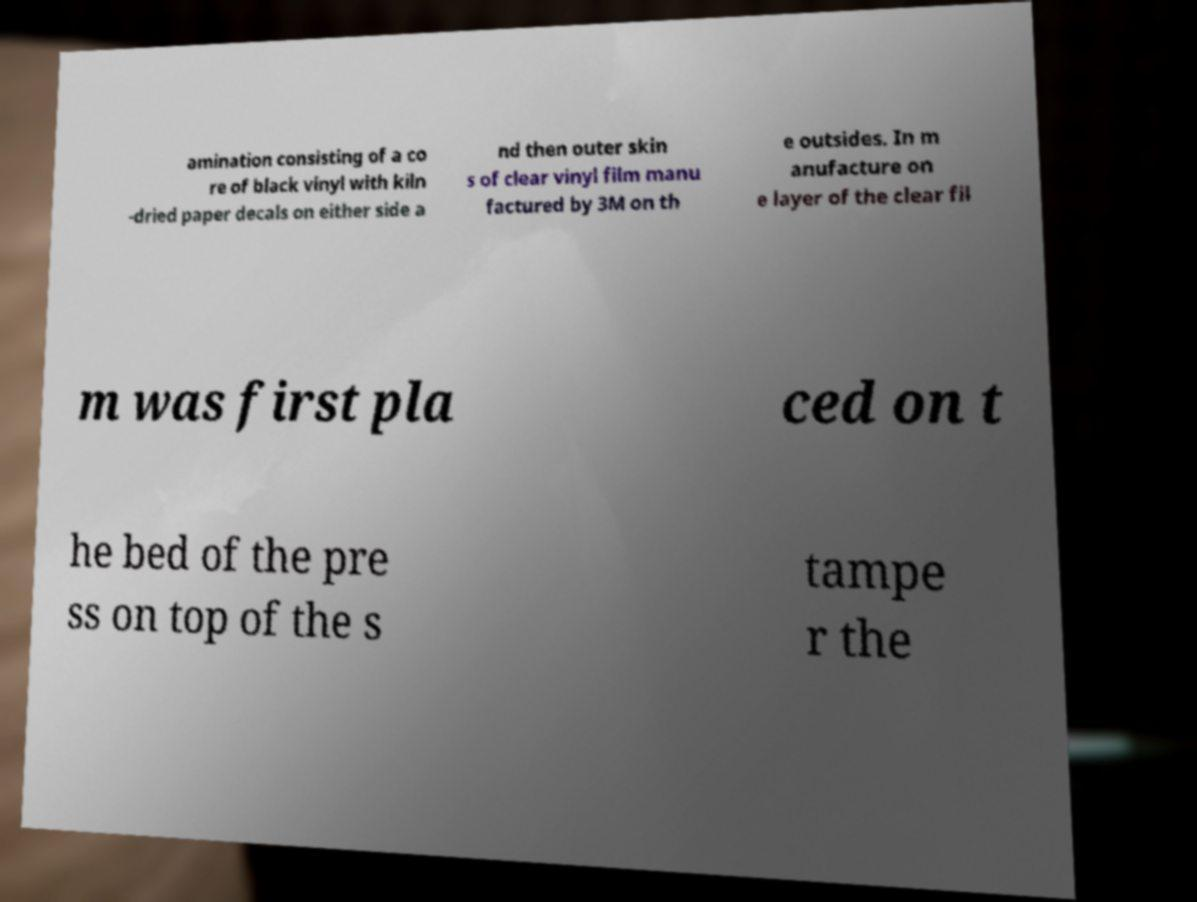Could you extract and type out the text from this image? amination consisting of a co re of black vinyl with kiln -dried paper decals on either side a nd then outer skin s of clear vinyl film manu factured by 3M on th e outsides. In m anufacture on e layer of the clear fil m was first pla ced on t he bed of the pre ss on top of the s tampe r the 